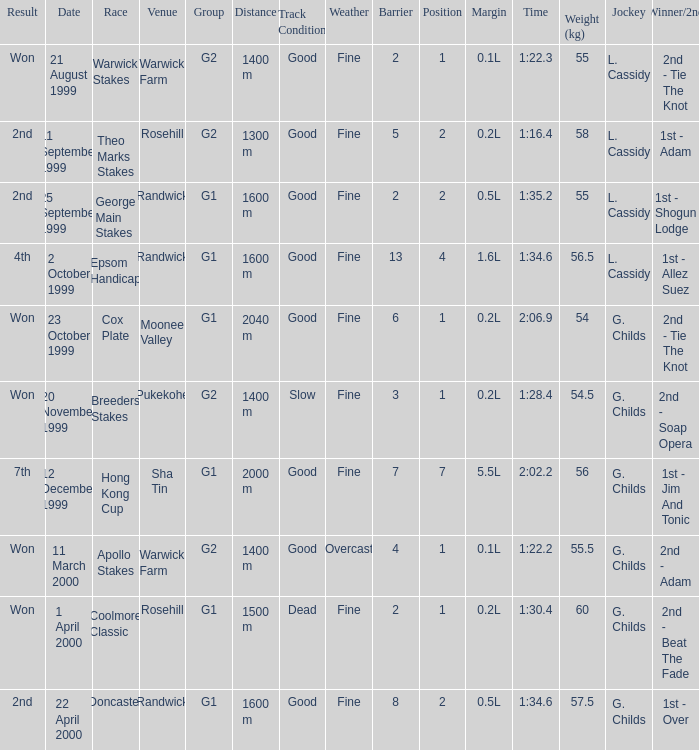How man teams had a total weight of 57.5? 1.0. 